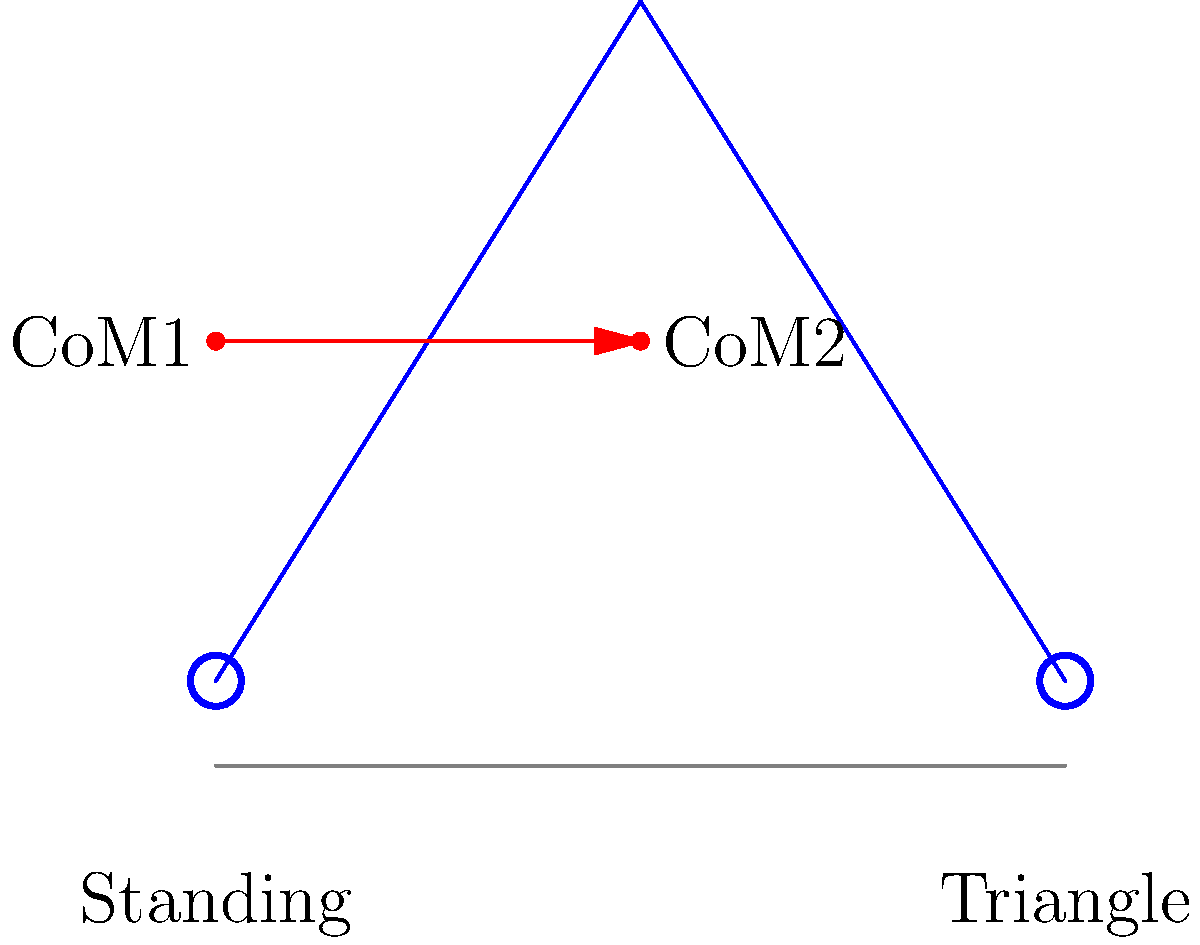In the transition from a standing pose to a triangle pose in yoga, how does the center of mass (CoM) shift, and what implications does this have for balance and stability? To understand the shift in the center of mass during the transition from a standing pose to a triangle pose, we need to consider the following steps:

1. Initial position (standing pose):
   - The CoM is typically located near the center of the body, approximately at the level of the lower abdomen.
   - In the standing pose, the CoM is vertically aligned with the base of support (feet).

2. Transition to triangle pose:
   - As the practitioner moves into the triangle pose, they extend one leg to the side and bend laterally at the waist.
   - This movement causes a redistribution of body mass.

3. Final position (triangle pose):
   - The CoM shifts laterally towards the extended leg and slightly downwards.
   - The vertical projection of the CoM is now closer to the edge of the base of support.

4. Implications for balance and stability:
   - The lateral shift of the CoM challenges the practitioner's balance.
   - The distance between the CoM projection and the edge of the base of support (stability margin) decreases.
   - This reduced stability margin requires increased muscle activation and proprioception to maintain balance.

5. Biomechanical analysis:
   - The moment arm between the CoM and the base of support increases in the triangle pose.
   - This increased moment arm results in a greater torque that must be countered by the muscles to maintain stability.
   - The equation for torque is: $$\tau = F \times d$$
     where $\tau$ is torque, $F$ is force (body weight), and $d$ is the perpendicular distance from the line of action of the force to the axis of rotation.

6. Adaptation and training:
   - Regular practice of poses like the triangle pose can improve balance, proprioception, and core strength.
   - These improvements allow for better control of the CoM in various positions, enhancing overall stability in yoga practice.
Answer: The CoM shifts laterally and slightly downward, reducing the stability margin and requiring increased muscle activation for balance. 